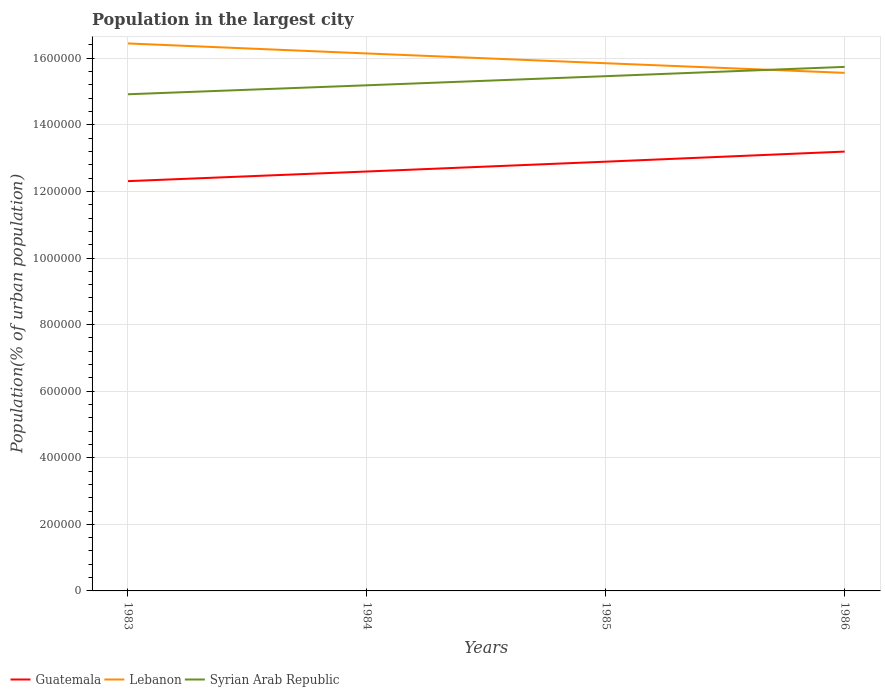How many different coloured lines are there?
Keep it short and to the point. 3. Is the number of lines equal to the number of legend labels?
Ensure brevity in your answer.  Yes. Across all years, what is the maximum population in the largest city in Syrian Arab Republic?
Your answer should be compact. 1.49e+06. What is the total population in the largest city in Guatemala in the graph?
Ensure brevity in your answer.  -3.03e+04. What is the difference between the highest and the second highest population in the largest city in Syrian Arab Republic?
Your answer should be compact. 8.23e+04. What is the difference between the highest and the lowest population in the largest city in Guatemala?
Provide a short and direct response. 2. Is the population in the largest city in Syrian Arab Republic strictly greater than the population in the largest city in Guatemala over the years?
Make the answer very short. No. How many years are there in the graph?
Offer a terse response. 4. What is the difference between two consecutive major ticks on the Y-axis?
Give a very brief answer. 2.00e+05. Are the values on the major ticks of Y-axis written in scientific E-notation?
Provide a succinct answer. No. Does the graph contain any zero values?
Provide a short and direct response. No. Does the graph contain grids?
Make the answer very short. Yes. How many legend labels are there?
Offer a terse response. 3. What is the title of the graph?
Your response must be concise. Population in the largest city. What is the label or title of the Y-axis?
Your response must be concise. Population(% of urban population). What is the Population(% of urban population) of Guatemala in 1983?
Keep it short and to the point. 1.23e+06. What is the Population(% of urban population) in Lebanon in 1983?
Keep it short and to the point. 1.64e+06. What is the Population(% of urban population) in Syrian Arab Republic in 1983?
Your response must be concise. 1.49e+06. What is the Population(% of urban population) of Guatemala in 1984?
Offer a very short reply. 1.26e+06. What is the Population(% of urban population) of Lebanon in 1984?
Ensure brevity in your answer.  1.61e+06. What is the Population(% of urban population) of Syrian Arab Republic in 1984?
Your answer should be compact. 1.52e+06. What is the Population(% of urban population) of Guatemala in 1985?
Ensure brevity in your answer.  1.29e+06. What is the Population(% of urban population) in Lebanon in 1985?
Provide a short and direct response. 1.59e+06. What is the Population(% of urban population) of Syrian Arab Republic in 1985?
Ensure brevity in your answer.  1.55e+06. What is the Population(% of urban population) in Guatemala in 1986?
Your answer should be compact. 1.32e+06. What is the Population(% of urban population) in Lebanon in 1986?
Your answer should be compact. 1.56e+06. What is the Population(% of urban population) of Syrian Arab Republic in 1986?
Your response must be concise. 1.57e+06. Across all years, what is the maximum Population(% of urban population) in Guatemala?
Ensure brevity in your answer.  1.32e+06. Across all years, what is the maximum Population(% of urban population) in Lebanon?
Your answer should be very brief. 1.64e+06. Across all years, what is the maximum Population(% of urban population) in Syrian Arab Republic?
Your answer should be compact. 1.57e+06. Across all years, what is the minimum Population(% of urban population) of Guatemala?
Give a very brief answer. 1.23e+06. Across all years, what is the minimum Population(% of urban population) of Lebanon?
Your answer should be compact. 1.56e+06. Across all years, what is the minimum Population(% of urban population) in Syrian Arab Republic?
Offer a very short reply. 1.49e+06. What is the total Population(% of urban population) in Guatemala in the graph?
Give a very brief answer. 5.10e+06. What is the total Population(% of urban population) of Lebanon in the graph?
Provide a succinct answer. 6.40e+06. What is the total Population(% of urban population) in Syrian Arab Republic in the graph?
Make the answer very short. 6.13e+06. What is the difference between the Population(% of urban population) of Guatemala in 1983 and that in 1984?
Keep it short and to the point. -2.90e+04. What is the difference between the Population(% of urban population) of Lebanon in 1983 and that in 1984?
Give a very brief answer. 3.00e+04. What is the difference between the Population(% of urban population) of Syrian Arab Republic in 1983 and that in 1984?
Your answer should be compact. -2.70e+04. What is the difference between the Population(% of urban population) of Guatemala in 1983 and that in 1985?
Ensure brevity in your answer.  -5.85e+04. What is the difference between the Population(% of urban population) of Lebanon in 1983 and that in 1985?
Make the answer very short. 5.94e+04. What is the difference between the Population(% of urban population) of Syrian Arab Republic in 1983 and that in 1985?
Your response must be concise. -5.44e+04. What is the difference between the Population(% of urban population) in Guatemala in 1983 and that in 1986?
Make the answer very short. -8.88e+04. What is the difference between the Population(% of urban population) in Lebanon in 1983 and that in 1986?
Make the answer very short. 8.83e+04. What is the difference between the Population(% of urban population) of Syrian Arab Republic in 1983 and that in 1986?
Your answer should be very brief. -8.23e+04. What is the difference between the Population(% of urban population) in Guatemala in 1984 and that in 1985?
Give a very brief answer. -2.96e+04. What is the difference between the Population(% of urban population) in Lebanon in 1984 and that in 1985?
Your answer should be compact. 2.94e+04. What is the difference between the Population(% of urban population) of Syrian Arab Republic in 1984 and that in 1985?
Your answer should be very brief. -2.74e+04. What is the difference between the Population(% of urban population) of Guatemala in 1984 and that in 1986?
Make the answer very short. -5.98e+04. What is the difference between the Population(% of urban population) of Lebanon in 1984 and that in 1986?
Your response must be concise. 5.83e+04. What is the difference between the Population(% of urban population) in Syrian Arab Republic in 1984 and that in 1986?
Make the answer very short. -5.53e+04. What is the difference between the Population(% of urban population) of Guatemala in 1985 and that in 1986?
Keep it short and to the point. -3.03e+04. What is the difference between the Population(% of urban population) in Lebanon in 1985 and that in 1986?
Provide a succinct answer. 2.89e+04. What is the difference between the Population(% of urban population) in Syrian Arab Republic in 1985 and that in 1986?
Your answer should be compact. -2.79e+04. What is the difference between the Population(% of urban population) of Guatemala in 1983 and the Population(% of urban population) of Lebanon in 1984?
Your response must be concise. -3.84e+05. What is the difference between the Population(% of urban population) of Guatemala in 1983 and the Population(% of urban population) of Syrian Arab Republic in 1984?
Give a very brief answer. -2.88e+05. What is the difference between the Population(% of urban population) in Lebanon in 1983 and the Population(% of urban population) in Syrian Arab Republic in 1984?
Ensure brevity in your answer.  1.26e+05. What is the difference between the Population(% of urban population) in Guatemala in 1983 and the Population(% of urban population) in Lebanon in 1985?
Provide a short and direct response. -3.54e+05. What is the difference between the Population(% of urban population) in Guatemala in 1983 and the Population(% of urban population) in Syrian Arab Republic in 1985?
Provide a succinct answer. -3.15e+05. What is the difference between the Population(% of urban population) in Lebanon in 1983 and the Population(% of urban population) in Syrian Arab Republic in 1985?
Give a very brief answer. 9.83e+04. What is the difference between the Population(% of urban population) of Guatemala in 1983 and the Population(% of urban population) of Lebanon in 1986?
Ensure brevity in your answer.  -3.25e+05. What is the difference between the Population(% of urban population) in Guatemala in 1983 and the Population(% of urban population) in Syrian Arab Republic in 1986?
Your answer should be very brief. -3.43e+05. What is the difference between the Population(% of urban population) of Lebanon in 1983 and the Population(% of urban population) of Syrian Arab Republic in 1986?
Your answer should be compact. 7.04e+04. What is the difference between the Population(% of urban population) of Guatemala in 1984 and the Population(% of urban population) of Lebanon in 1985?
Your answer should be compact. -3.25e+05. What is the difference between the Population(% of urban population) of Guatemala in 1984 and the Population(% of urban population) of Syrian Arab Republic in 1985?
Your answer should be compact. -2.86e+05. What is the difference between the Population(% of urban population) in Lebanon in 1984 and the Population(% of urban population) in Syrian Arab Republic in 1985?
Make the answer very short. 6.83e+04. What is the difference between the Population(% of urban population) in Guatemala in 1984 and the Population(% of urban population) in Lebanon in 1986?
Your response must be concise. -2.96e+05. What is the difference between the Population(% of urban population) of Guatemala in 1984 and the Population(% of urban population) of Syrian Arab Republic in 1986?
Offer a very short reply. -3.14e+05. What is the difference between the Population(% of urban population) in Lebanon in 1984 and the Population(% of urban population) in Syrian Arab Republic in 1986?
Give a very brief answer. 4.04e+04. What is the difference between the Population(% of urban population) in Guatemala in 1985 and the Population(% of urban population) in Lebanon in 1986?
Provide a succinct answer. -2.67e+05. What is the difference between the Population(% of urban population) of Guatemala in 1985 and the Population(% of urban population) of Syrian Arab Republic in 1986?
Ensure brevity in your answer.  -2.85e+05. What is the difference between the Population(% of urban population) of Lebanon in 1985 and the Population(% of urban population) of Syrian Arab Republic in 1986?
Ensure brevity in your answer.  1.10e+04. What is the average Population(% of urban population) in Guatemala per year?
Keep it short and to the point. 1.27e+06. What is the average Population(% of urban population) in Lebanon per year?
Make the answer very short. 1.60e+06. What is the average Population(% of urban population) of Syrian Arab Republic per year?
Your response must be concise. 1.53e+06. In the year 1983, what is the difference between the Population(% of urban population) in Guatemala and Population(% of urban population) in Lebanon?
Make the answer very short. -4.14e+05. In the year 1983, what is the difference between the Population(% of urban population) in Guatemala and Population(% of urban population) in Syrian Arab Republic?
Offer a very short reply. -2.61e+05. In the year 1983, what is the difference between the Population(% of urban population) of Lebanon and Population(% of urban population) of Syrian Arab Republic?
Your answer should be very brief. 1.53e+05. In the year 1984, what is the difference between the Population(% of urban population) in Guatemala and Population(% of urban population) in Lebanon?
Give a very brief answer. -3.55e+05. In the year 1984, what is the difference between the Population(% of urban population) in Guatemala and Population(% of urban population) in Syrian Arab Republic?
Make the answer very short. -2.59e+05. In the year 1984, what is the difference between the Population(% of urban population) of Lebanon and Population(% of urban population) of Syrian Arab Republic?
Keep it short and to the point. 9.56e+04. In the year 1985, what is the difference between the Population(% of urban population) of Guatemala and Population(% of urban population) of Lebanon?
Give a very brief answer. -2.96e+05. In the year 1985, what is the difference between the Population(% of urban population) of Guatemala and Population(% of urban population) of Syrian Arab Republic?
Make the answer very short. -2.57e+05. In the year 1985, what is the difference between the Population(% of urban population) in Lebanon and Population(% of urban population) in Syrian Arab Republic?
Your answer should be very brief. 3.89e+04. In the year 1986, what is the difference between the Population(% of urban population) of Guatemala and Population(% of urban population) of Lebanon?
Offer a terse response. -2.37e+05. In the year 1986, what is the difference between the Population(% of urban population) of Guatemala and Population(% of urban population) of Syrian Arab Republic?
Offer a terse response. -2.54e+05. In the year 1986, what is the difference between the Population(% of urban population) in Lebanon and Population(% of urban population) in Syrian Arab Republic?
Give a very brief answer. -1.79e+04. What is the ratio of the Population(% of urban population) of Guatemala in 1983 to that in 1984?
Your answer should be very brief. 0.98. What is the ratio of the Population(% of urban population) of Lebanon in 1983 to that in 1984?
Your answer should be compact. 1.02. What is the ratio of the Population(% of urban population) in Syrian Arab Republic in 1983 to that in 1984?
Provide a succinct answer. 0.98. What is the ratio of the Population(% of urban population) of Guatemala in 1983 to that in 1985?
Your answer should be very brief. 0.95. What is the ratio of the Population(% of urban population) of Lebanon in 1983 to that in 1985?
Make the answer very short. 1.04. What is the ratio of the Population(% of urban population) in Syrian Arab Republic in 1983 to that in 1985?
Give a very brief answer. 0.96. What is the ratio of the Population(% of urban population) in Guatemala in 1983 to that in 1986?
Offer a terse response. 0.93. What is the ratio of the Population(% of urban population) of Lebanon in 1983 to that in 1986?
Provide a succinct answer. 1.06. What is the ratio of the Population(% of urban population) in Syrian Arab Republic in 1983 to that in 1986?
Provide a short and direct response. 0.95. What is the ratio of the Population(% of urban population) in Guatemala in 1984 to that in 1985?
Your response must be concise. 0.98. What is the ratio of the Population(% of urban population) in Lebanon in 1984 to that in 1985?
Your response must be concise. 1.02. What is the ratio of the Population(% of urban population) in Syrian Arab Republic in 1984 to that in 1985?
Ensure brevity in your answer.  0.98. What is the ratio of the Population(% of urban population) in Guatemala in 1984 to that in 1986?
Your answer should be compact. 0.95. What is the ratio of the Population(% of urban population) of Lebanon in 1984 to that in 1986?
Provide a short and direct response. 1.04. What is the ratio of the Population(% of urban population) in Syrian Arab Republic in 1984 to that in 1986?
Your response must be concise. 0.96. What is the ratio of the Population(% of urban population) of Lebanon in 1985 to that in 1986?
Keep it short and to the point. 1.02. What is the ratio of the Population(% of urban population) in Syrian Arab Republic in 1985 to that in 1986?
Your answer should be very brief. 0.98. What is the difference between the highest and the second highest Population(% of urban population) in Guatemala?
Make the answer very short. 3.03e+04. What is the difference between the highest and the second highest Population(% of urban population) of Lebanon?
Ensure brevity in your answer.  3.00e+04. What is the difference between the highest and the second highest Population(% of urban population) of Syrian Arab Republic?
Your response must be concise. 2.79e+04. What is the difference between the highest and the lowest Population(% of urban population) in Guatemala?
Ensure brevity in your answer.  8.88e+04. What is the difference between the highest and the lowest Population(% of urban population) in Lebanon?
Keep it short and to the point. 8.83e+04. What is the difference between the highest and the lowest Population(% of urban population) in Syrian Arab Republic?
Your answer should be very brief. 8.23e+04. 